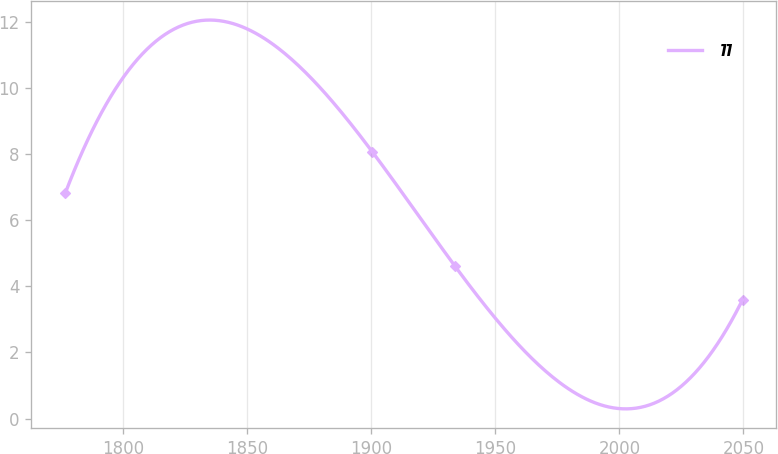<chart> <loc_0><loc_0><loc_500><loc_500><line_chart><ecel><fcel>11<nl><fcel>1776.75<fcel>6.81<nl><fcel>1900.49<fcel>8.06<nl><fcel>1933.65<fcel>4.62<nl><fcel>2049.64<fcel>3.59<nl></chart> 